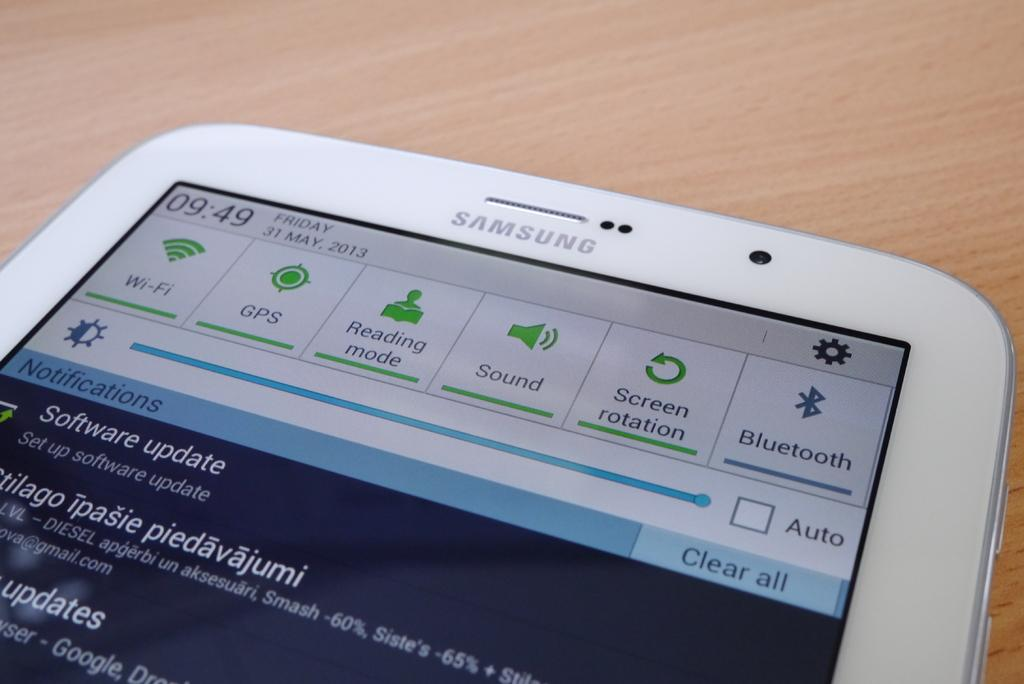<image>
Render a clear and concise summary of the photo. A Samsung phone shows that the time is 09:49. 